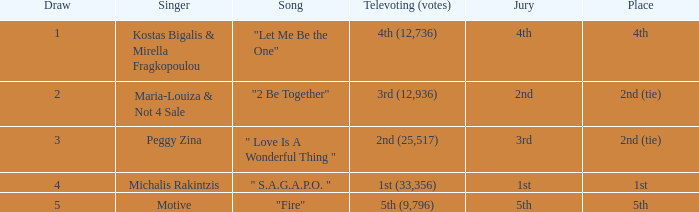Singer Maria-Louiza & Not 4 Sale had what jury? 2nd. 